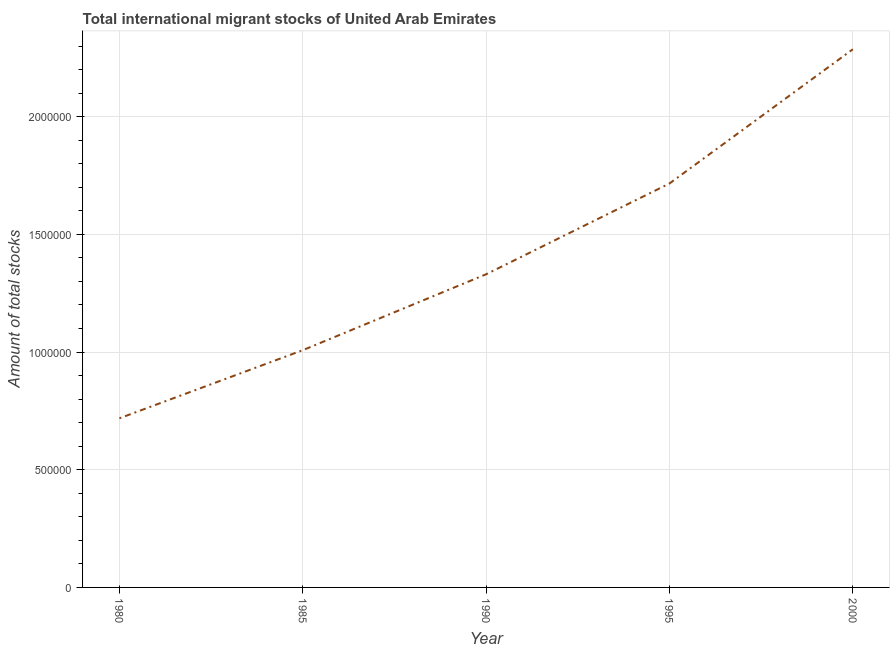What is the total number of international migrant stock in 1990?
Make the answer very short. 1.33e+06. Across all years, what is the maximum total number of international migrant stock?
Your answer should be very brief. 2.29e+06. Across all years, what is the minimum total number of international migrant stock?
Make the answer very short. 7.18e+05. In which year was the total number of international migrant stock maximum?
Keep it short and to the point. 2000. In which year was the total number of international migrant stock minimum?
Provide a short and direct response. 1980. What is the sum of the total number of international migrant stock?
Provide a short and direct response. 7.06e+06. What is the difference between the total number of international migrant stock in 1985 and 2000?
Keep it short and to the point. -1.28e+06. What is the average total number of international migrant stock per year?
Make the answer very short. 1.41e+06. What is the median total number of international migrant stock?
Provide a short and direct response. 1.33e+06. What is the ratio of the total number of international migrant stock in 1980 to that in 1990?
Offer a terse response. 0.54. Is the total number of international migrant stock in 1980 less than that in 1985?
Your answer should be compact. Yes. Is the difference between the total number of international migrant stock in 1995 and 2000 greater than the difference between any two years?
Your answer should be very brief. No. What is the difference between the highest and the second highest total number of international migrant stock?
Keep it short and to the point. 5.70e+05. What is the difference between the highest and the lowest total number of international migrant stock?
Provide a succinct answer. 1.57e+06. How many lines are there?
Provide a short and direct response. 1. Are the values on the major ticks of Y-axis written in scientific E-notation?
Your answer should be compact. No. Does the graph contain any zero values?
Offer a very short reply. No. Does the graph contain grids?
Give a very brief answer. Yes. What is the title of the graph?
Your response must be concise. Total international migrant stocks of United Arab Emirates. What is the label or title of the Y-axis?
Ensure brevity in your answer.  Amount of total stocks. What is the Amount of total stocks in 1980?
Offer a terse response. 7.18e+05. What is the Amount of total stocks in 1985?
Provide a succinct answer. 1.01e+06. What is the Amount of total stocks of 1990?
Your response must be concise. 1.33e+06. What is the Amount of total stocks of 1995?
Ensure brevity in your answer.  1.72e+06. What is the Amount of total stocks of 2000?
Offer a terse response. 2.29e+06. What is the difference between the Amount of total stocks in 1980 and 1985?
Your answer should be compact. -2.89e+05. What is the difference between the Amount of total stocks in 1980 and 1990?
Your response must be concise. -6.12e+05. What is the difference between the Amount of total stocks in 1980 and 1995?
Offer a terse response. -9.98e+05. What is the difference between the Amount of total stocks in 1980 and 2000?
Offer a very short reply. -1.57e+06. What is the difference between the Amount of total stocks in 1985 and 1990?
Provide a succinct answer. -3.22e+05. What is the difference between the Amount of total stocks in 1985 and 1995?
Offer a terse response. -7.08e+05. What is the difference between the Amount of total stocks in 1985 and 2000?
Keep it short and to the point. -1.28e+06. What is the difference between the Amount of total stocks in 1990 and 1995?
Provide a succinct answer. -3.86e+05. What is the difference between the Amount of total stocks in 1990 and 2000?
Give a very brief answer. -9.56e+05. What is the difference between the Amount of total stocks in 1995 and 2000?
Give a very brief answer. -5.70e+05. What is the ratio of the Amount of total stocks in 1980 to that in 1985?
Offer a terse response. 0.71. What is the ratio of the Amount of total stocks in 1980 to that in 1990?
Give a very brief answer. 0.54. What is the ratio of the Amount of total stocks in 1980 to that in 1995?
Provide a short and direct response. 0.42. What is the ratio of the Amount of total stocks in 1980 to that in 2000?
Give a very brief answer. 0.31. What is the ratio of the Amount of total stocks in 1985 to that in 1990?
Offer a very short reply. 0.76. What is the ratio of the Amount of total stocks in 1985 to that in 1995?
Your answer should be compact. 0.59. What is the ratio of the Amount of total stocks in 1985 to that in 2000?
Give a very brief answer. 0.44. What is the ratio of the Amount of total stocks in 1990 to that in 1995?
Your answer should be compact. 0.78. What is the ratio of the Amount of total stocks in 1990 to that in 2000?
Provide a short and direct response. 0.58. What is the ratio of the Amount of total stocks in 1995 to that in 2000?
Provide a succinct answer. 0.75. 